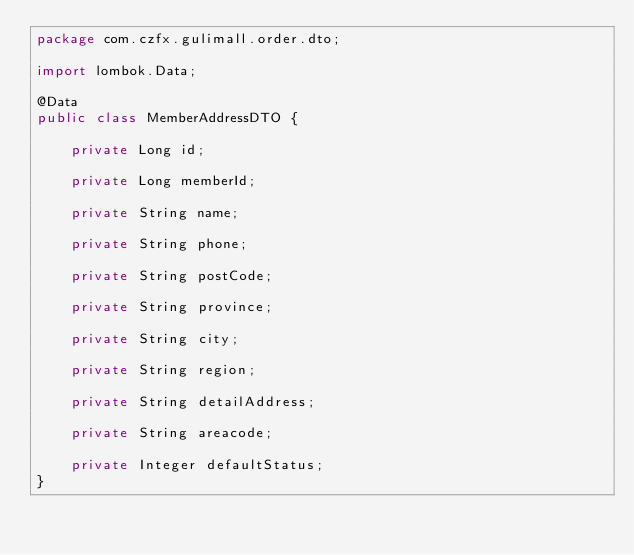Convert code to text. <code><loc_0><loc_0><loc_500><loc_500><_Java_>package com.czfx.gulimall.order.dto;

import lombok.Data;

@Data
public class MemberAddressDTO {

    private Long id;

    private Long memberId;

    private String name;

    private String phone;

    private String postCode;

    private String province;

    private String city;

    private String region;

    private String detailAddress;

    private String areacode;

    private Integer defaultStatus;
}
</code> 